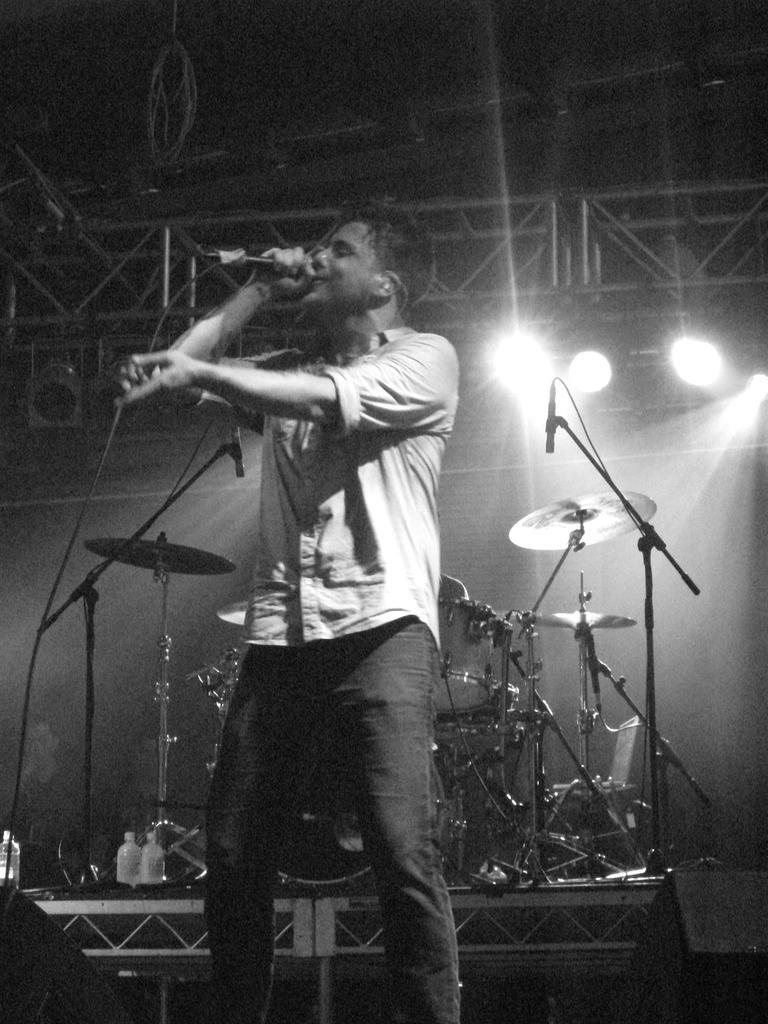In one or two sentences, can you explain what this image depicts? In the picture we can see a man standing and singing a song in the microphone and holding it behind him and we can see an orchestra set and behind it we can see some lights to the stand. 